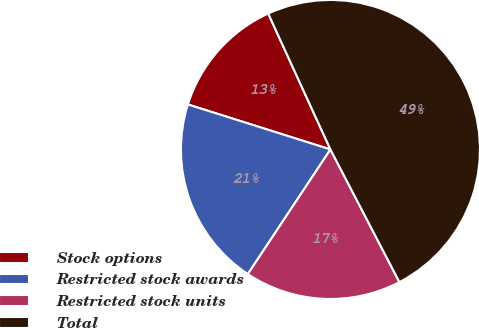<chart> <loc_0><loc_0><loc_500><loc_500><pie_chart><fcel>Stock options<fcel>Restricted stock awards<fcel>Restricted stock units<fcel>Total<nl><fcel>13.3%<fcel>20.55%<fcel>16.95%<fcel>49.2%<nl></chart> 